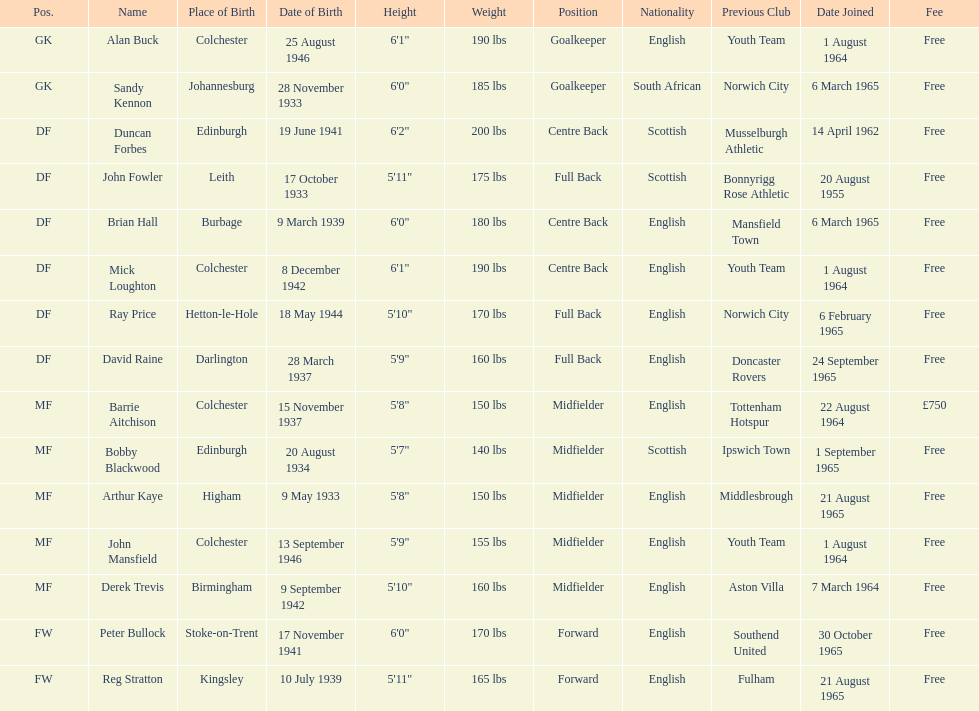When did each player join? 1 August 1964, 6 March 1965, 14 April 1962, 20 August 1955, 6 March 1965, 1 August 1964, 6 February 1965, 24 September 1965, 22 August 1964, 1 September 1965, 21 August 1965, 1 August 1964, 7 March 1964, 30 October 1965, 21 August 1965. And of those, which is the earliest join date? 20 August 1955. 